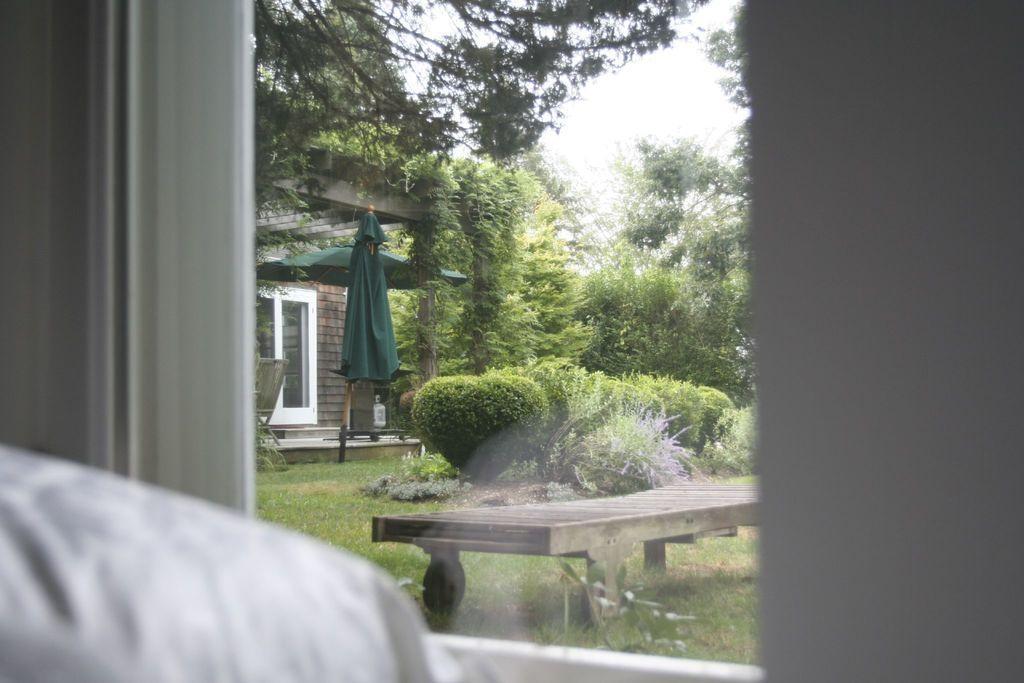Describe this image in one or two sentences. Here in this picture, through a glass window we can see a bench present on the ground, which is fully covered with grass over there and we can see plants, bushes and trees all over there and we can also see an umbrella present over there and we can see a house also present over there. 